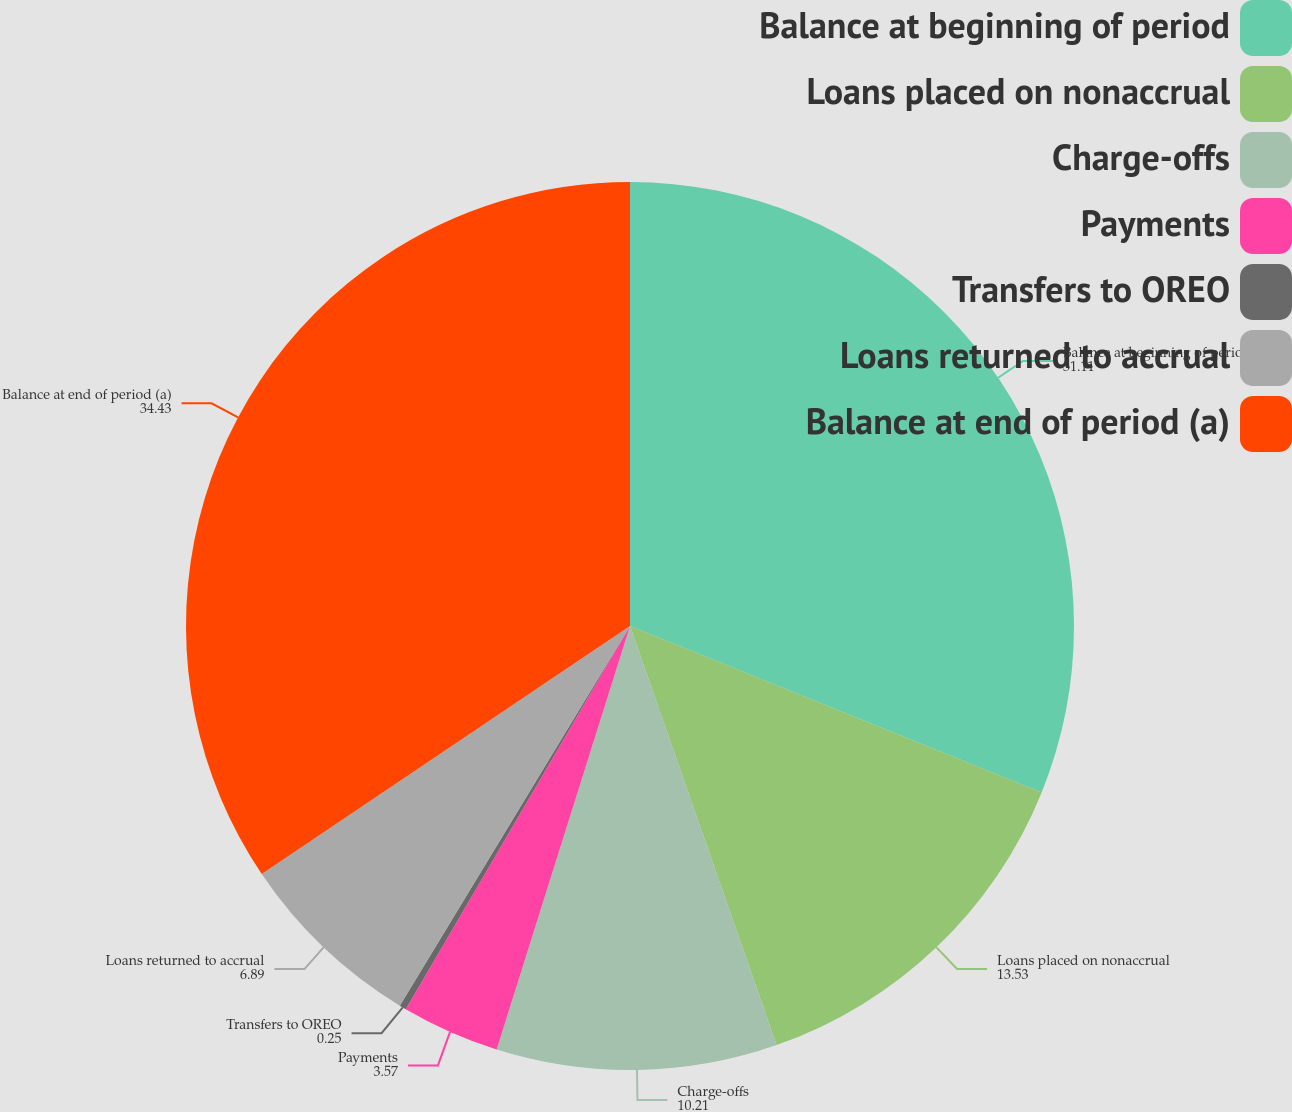Convert chart. <chart><loc_0><loc_0><loc_500><loc_500><pie_chart><fcel>Balance at beginning of period<fcel>Loans placed on nonaccrual<fcel>Charge-offs<fcel>Payments<fcel>Transfers to OREO<fcel>Loans returned to accrual<fcel>Balance at end of period (a)<nl><fcel>31.11%<fcel>13.53%<fcel>10.21%<fcel>3.57%<fcel>0.25%<fcel>6.89%<fcel>34.43%<nl></chart> 